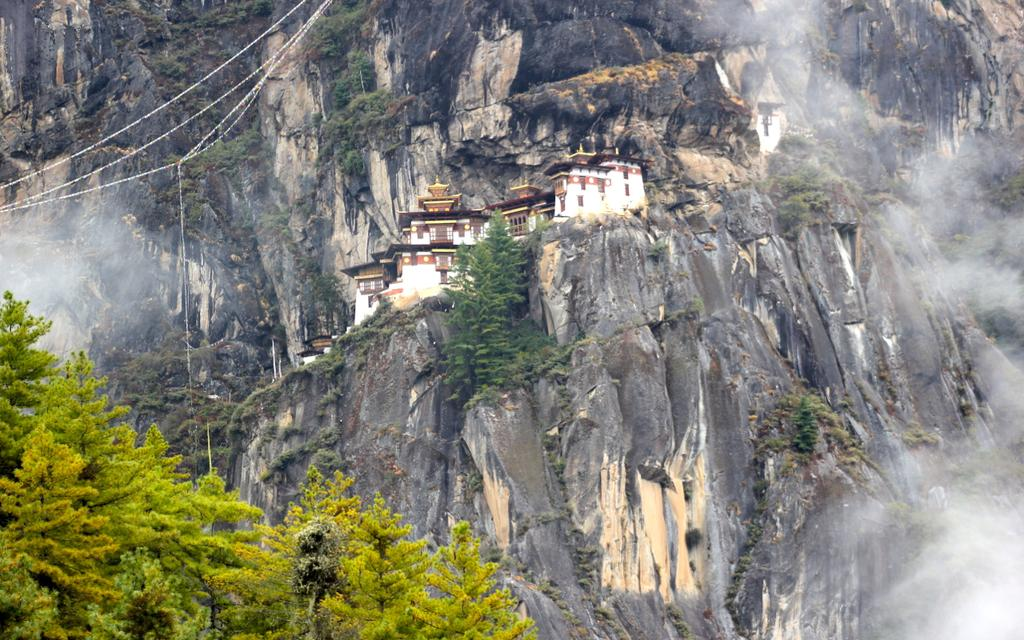What type of natural formation is present in the image? There is a rock mountain in the image. What type of vegetation can be seen in the image? There are many trees in the image. What type of man-made structures are visible in the image? There are buildings in the image. What type of equipment or tools can be seen in the image? There are ropes in the image. What type of insect can be seen writing a message on the rock mountain in the image? There are no insects or messages present in the image; it features a rock mountain, trees, buildings, and ropes. 